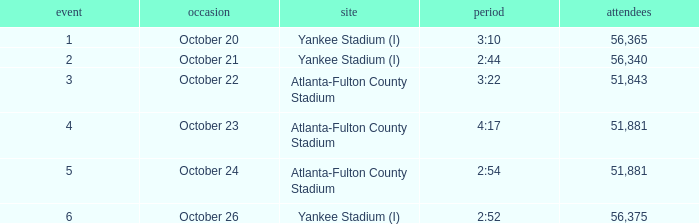What is the highest game number that had a time of 2:44? 2.0. 